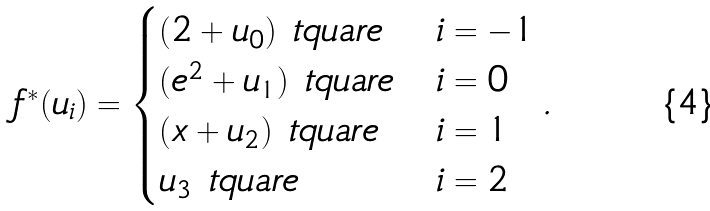<formula> <loc_0><loc_0><loc_500><loc_500>f ^ { * } ( u _ { i } ) = \begin{cases} ( 2 + u _ { 0 } ) \ t q u a r e & i = - 1 \\ ( e ^ { 2 } + u _ { 1 } ) \ t q u a r e & i = 0 \\ ( x + u _ { 2 } ) \ t q u a r e & i = 1 \\ u _ { 3 } \ t q u a r e & i = 2 \end{cases} .</formula> 